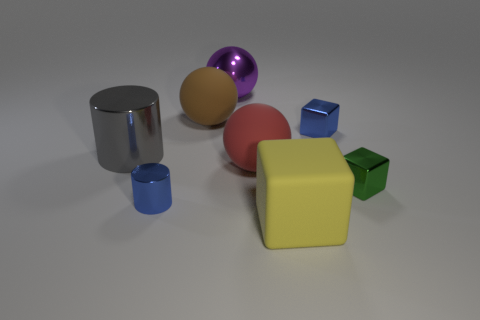Add 1 red matte objects. How many objects exist? 9 Subtract all gray cylinders. How many cylinders are left? 1 Subtract all blue metal cubes. How many cubes are left? 2 Subtract 1 gray cylinders. How many objects are left? 7 Subtract all cubes. How many objects are left? 5 Subtract 1 cylinders. How many cylinders are left? 1 Subtract all yellow cubes. Subtract all green balls. How many cubes are left? 2 Subtract all cyan cylinders. How many purple spheres are left? 1 Subtract all shiny cylinders. Subtract all small blocks. How many objects are left? 4 Add 5 large gray shiny cylinders. How many large gray shiny cylinders are left? 6 